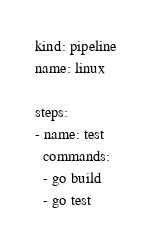Convert code to text. <code><loc_0><loc_0><loc_500><loc_500><_YAML_>kind: pipeline
name: linux

steps:
- name: test
  commands:
  - go build
  - go test
</code> 